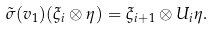<formula> <loc_0><loc_0><loc_500><loc_500>\tilde { \sigma } ( v _ { 1 } ) ( \xi _ { i } \otimes \eta ) = \xi _ { i + 1 } \otimes U _ { i } \eta .</formula> 